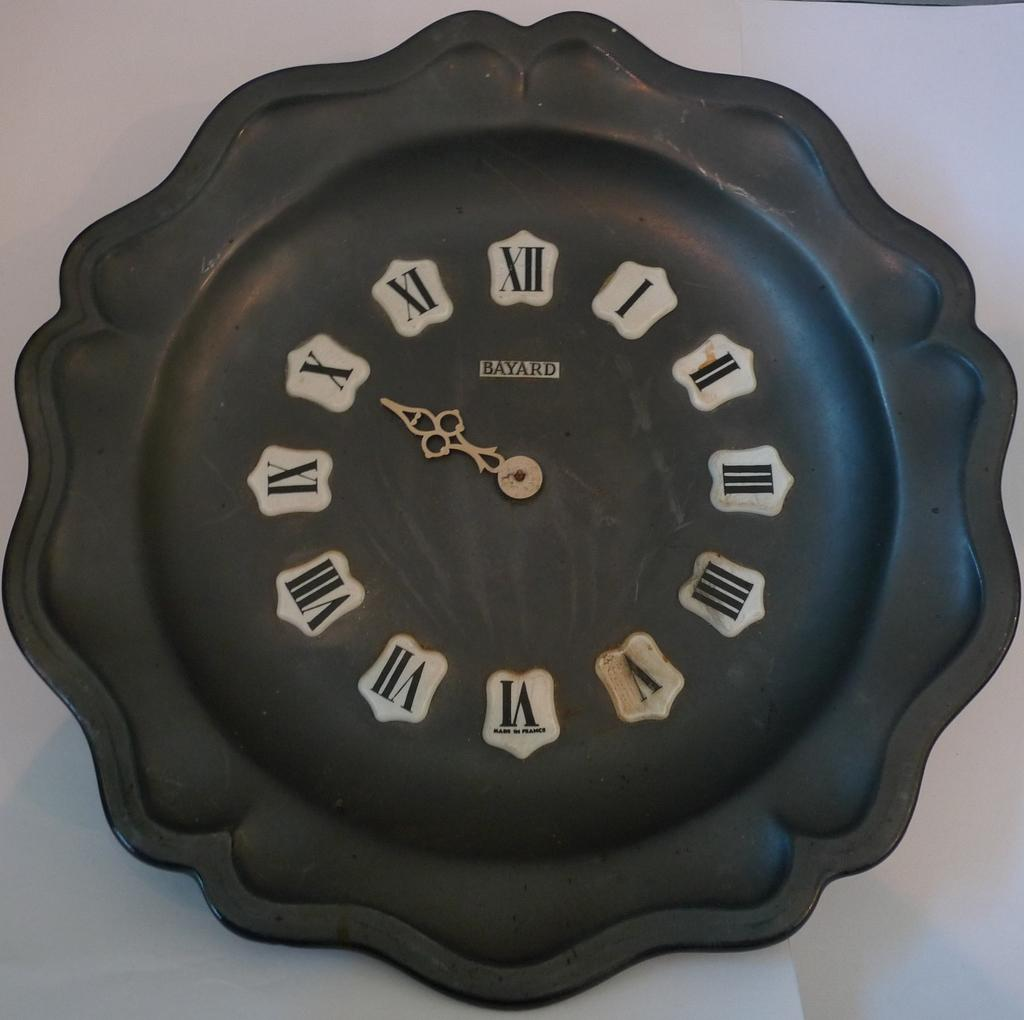<image>
Describe the image concisely. A unique black clocked filled with silver-played numbers and a gold hand 